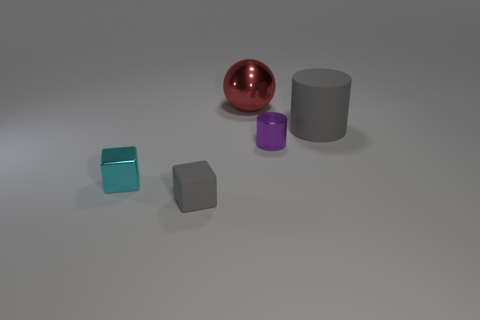Imagine these objects were part of an art installation. What themes could they represent? The various geometric shapes and colors could symbolize diversity and harmony within a community, illustrating how multiple unique entities coexist together. The pristine, unadorned presentation might suggest themes of simplicity and minimalism, inviting observers to reflect on the beauty of fundamental forms and hues in contrast to our often chaotic and embellished world. 